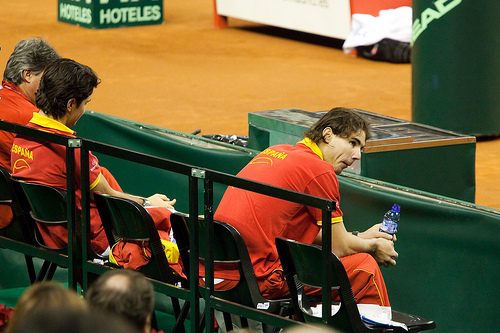<image>
Can you confirm if the head is on the table? No. The head is not positioned on the table. They may be near each other, but the head is not supported by or resting on top of the table. Is there a fence behind the man? Yes. From this viewpoint, the fence is positioned behind the man, with the man partially or fully occluding the fence. 